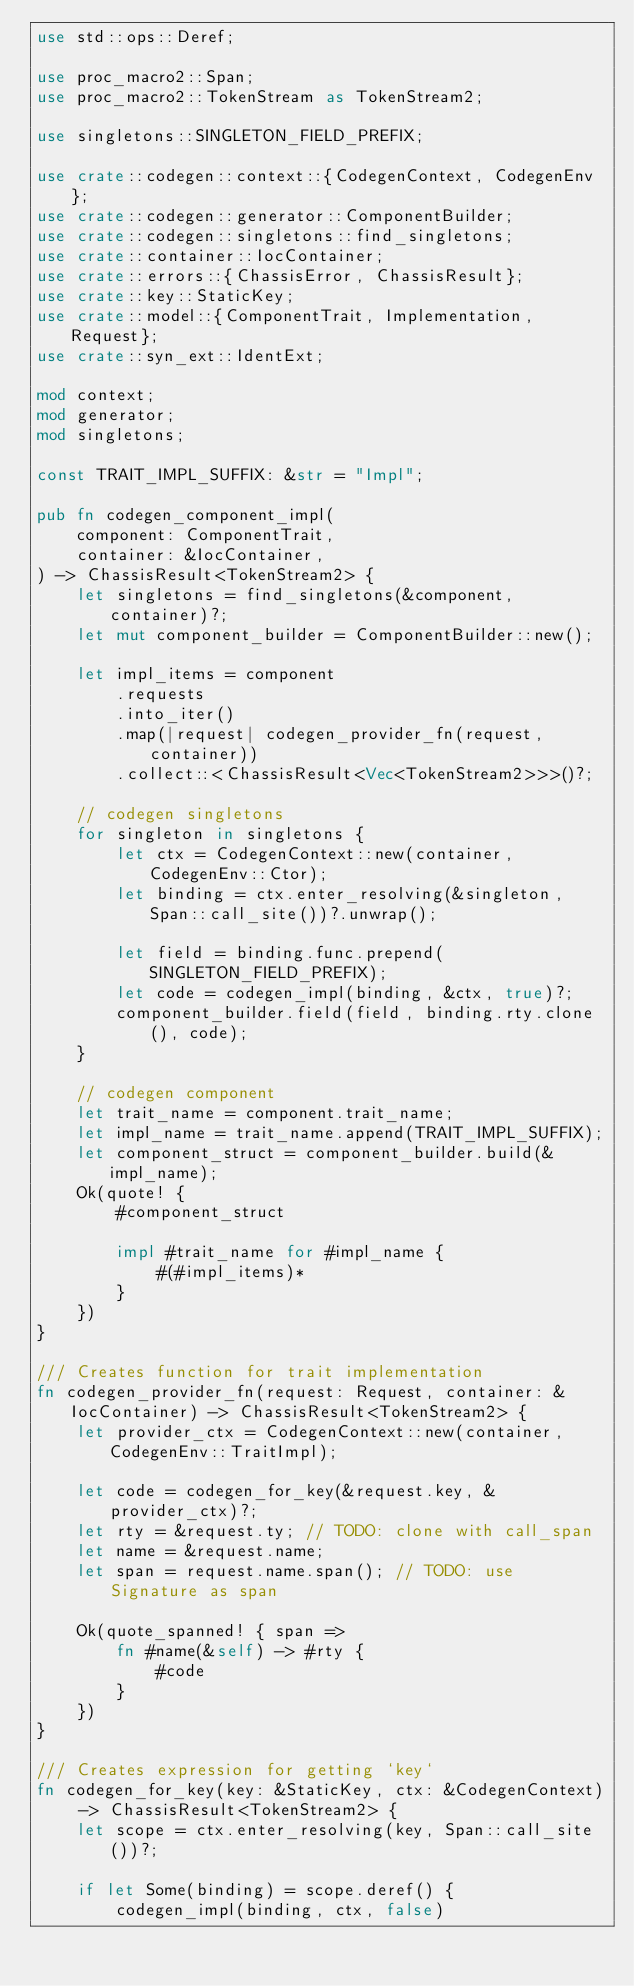Convert code to text. <code><loc_0><loc_0><loc_500><loc_500><_Rust_>use std::ops::Deref;

use proc_macro2::Span;
use proc_macro2::TokenStream as TokenStream2;

use singletons::SINGLETON_FIELD_PREFIX;

use crate::codegen::context::{CodegenContext, CodegenEnv};
use crate::codegen::generator::ComponentBuilder;
use crate::codegen::singletons::find_singletons;
use crate::container::IocContainer;
use crate::errors::{ChassisError, ChassisResult};
use crate::key::StaticKey;
use crate::model::{ComponentTrait, Implementation, Request};
use crate::syn_ext::IdentExt;

mod context;
mod generator;
mod singletons;

const TRAIT_IMPL_SUFFIX: &str = "Impl";

pub fn codegen_component_impl(
    component: ComponentTrait,
    container: &IocContainer,
) -> ChassisResult<TokenStream2> {
    let singletons = find_singletons(&component, container)?;
    let mut component_builder = ComponentBuilder::new();

    let impl_items = component
        .requests
        .into_iter()
        .map(|request| codegen_provider_fn(request, container))
        .collect::<ChassisResult<Vec<TokenStream2>>>()?;

    // codegen singletons
    for singleton in singletons {
        let ctx = CodegenContext::new(container, CodegenEnv::Ctor);
        let binding = ctx.enter_resolving(&singleton, Span::call_site())?.unwrap();

        let field = binding.func.prepend(SINGLETON_FIELD_PREFIX);
        let code = codegen_impl(binding, &ctx, true)?;
        component_builder.field(field, binding.rty.clone(), code);
    }

    // codegen component
    let trait_name = component.trait_name;
    let impl_name = trait_name.append(TRAIT_IMPL_SUFFIX);
    let component_struct = component_builder.build(&impl_name);
    Ok(quote! {
        #component_struct

        impl #trait_name for #impl_name {
            #(#impl_items)*
        }
    })
}

/// Creates function for trait implementation
fn codegen_provider_fn(request: Request, container: &IocContainer) -> ChassisResult<TokenStream2> {
    let provider_ctx = CodegenContext::new(container, CodegenEnv::TraitImpl);

    let code = codegen_for_key(&request.key, &provider_ctx)?;
    let rty = &request.ty; // TODO: clone with call_span
    let name = &request.name;
    let span = request.name.span(); // TODO: use Signature as span

    Ok(quote_spanned! { span =>
        fn #name(&self) -> #rty {
            #code
        }
    })
}

/// Creates expression for getting `key`
fn codegen_for_key(key: &StaticKey, ctx: &CodegenContext) -> ChassisResult<TokenStream2> {
    let scope = ctx.enter_resolving(key, Span::call_site())?;

    if let Some(binding) = scope.deref() {
        codegen_impl(binding, ctx, false)</code> 